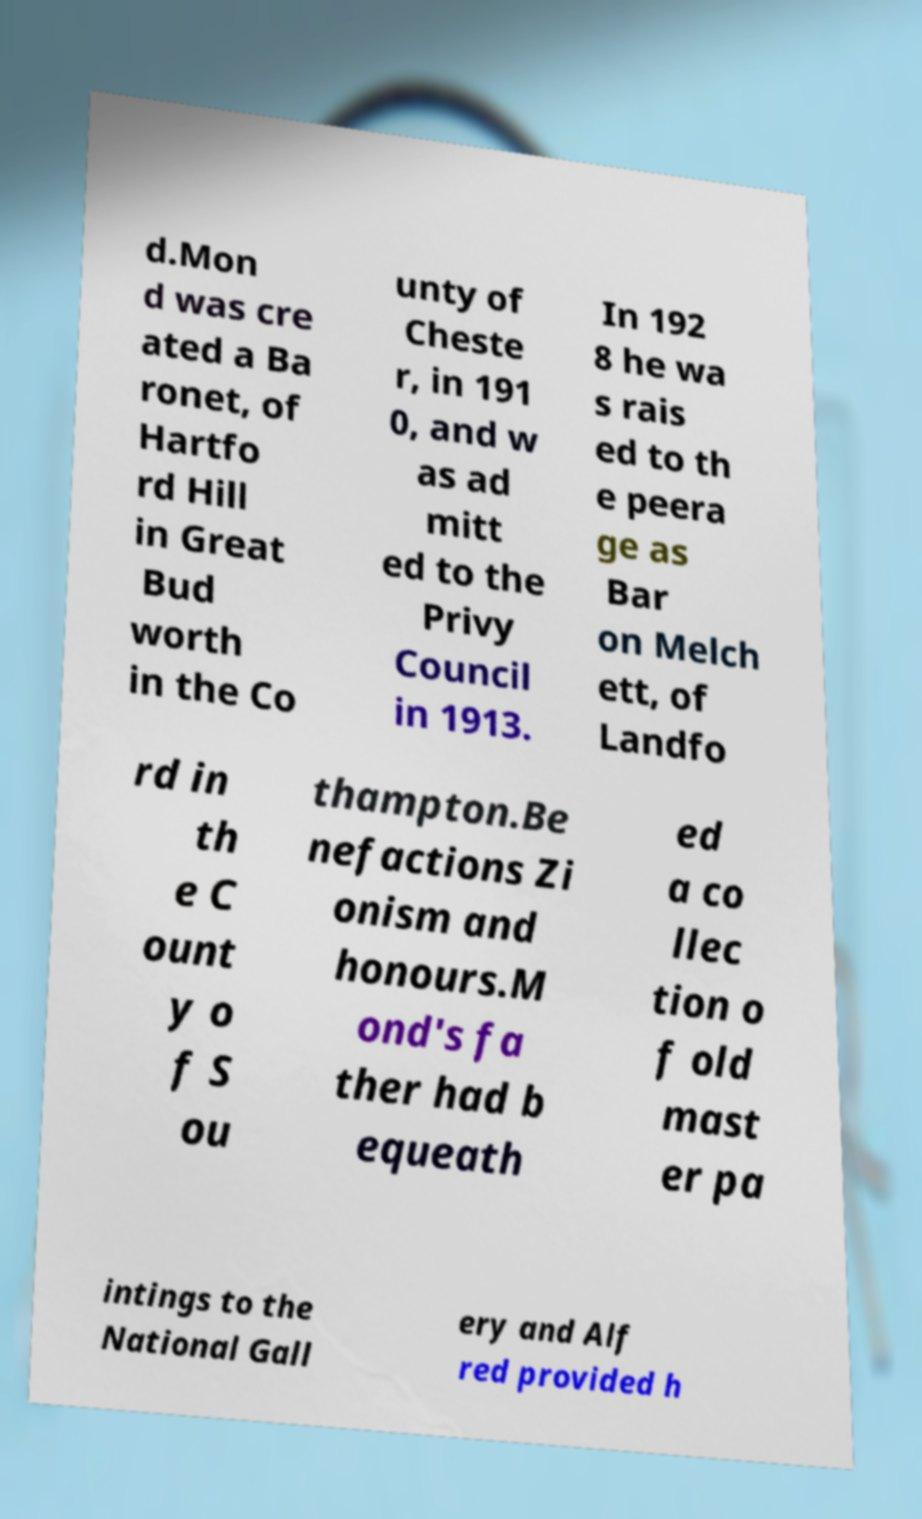Can you read and provide the text displayed in the image?This photo seems to have some interesting text. Can you extract and type it out for me? d.Mon d was cre ated a Ba ronet, of Hartfo rd Hill in Great Bud worth in the Co unty of Cheste r, in 191 0, and w as ad mitt ed to the Privy Council in 1913. In 192 8 he wa s rais ed to th e peera ge as Bar on Melch ett, of Landfo rd in th e C ount y o f S ou thampton.Be nefactions Zi onism and honours.M ond's fa ther had b equeath ed a co llec tion o f old mast er pa intings to the National Gall ery and Alf red provided h 